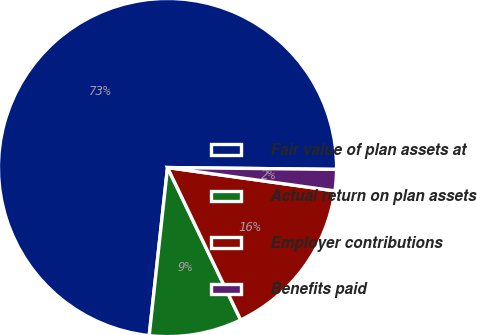<chart> <loc_0><loc_0><loc_500><loc_500><pie_chart><fcel>Fair value of plan assets at<fcel>Actual return on plan assets<fcel>Employer contributions<fcel>Benefits paid<nl><fcel>73.44%<fcel>8.85%<fcel>15.67%<fcel>2.03%<nl></chart> 